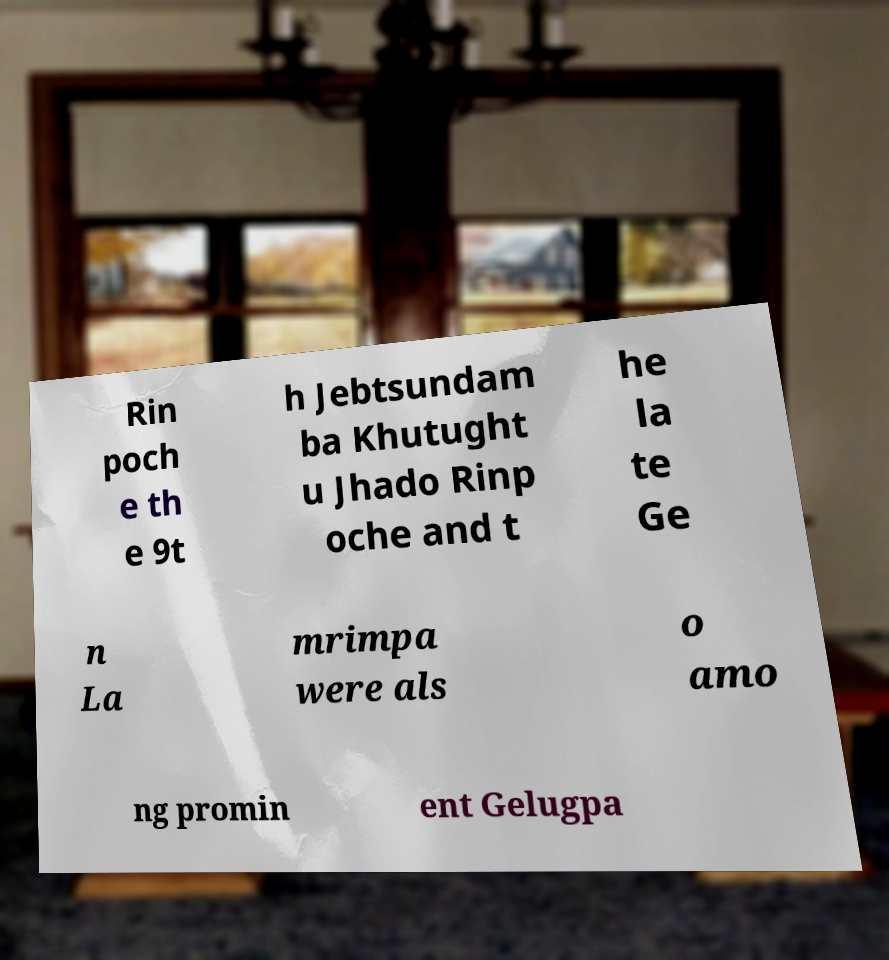Could you assist in decoding the text presented in this image and type it out clearly? Rin poch e th e 9t h Jebtsundam ba Khutught u Jhado Rinp oche and t he la te Ge n La mrimpa were als o amo ng promin ent Gelugpa 